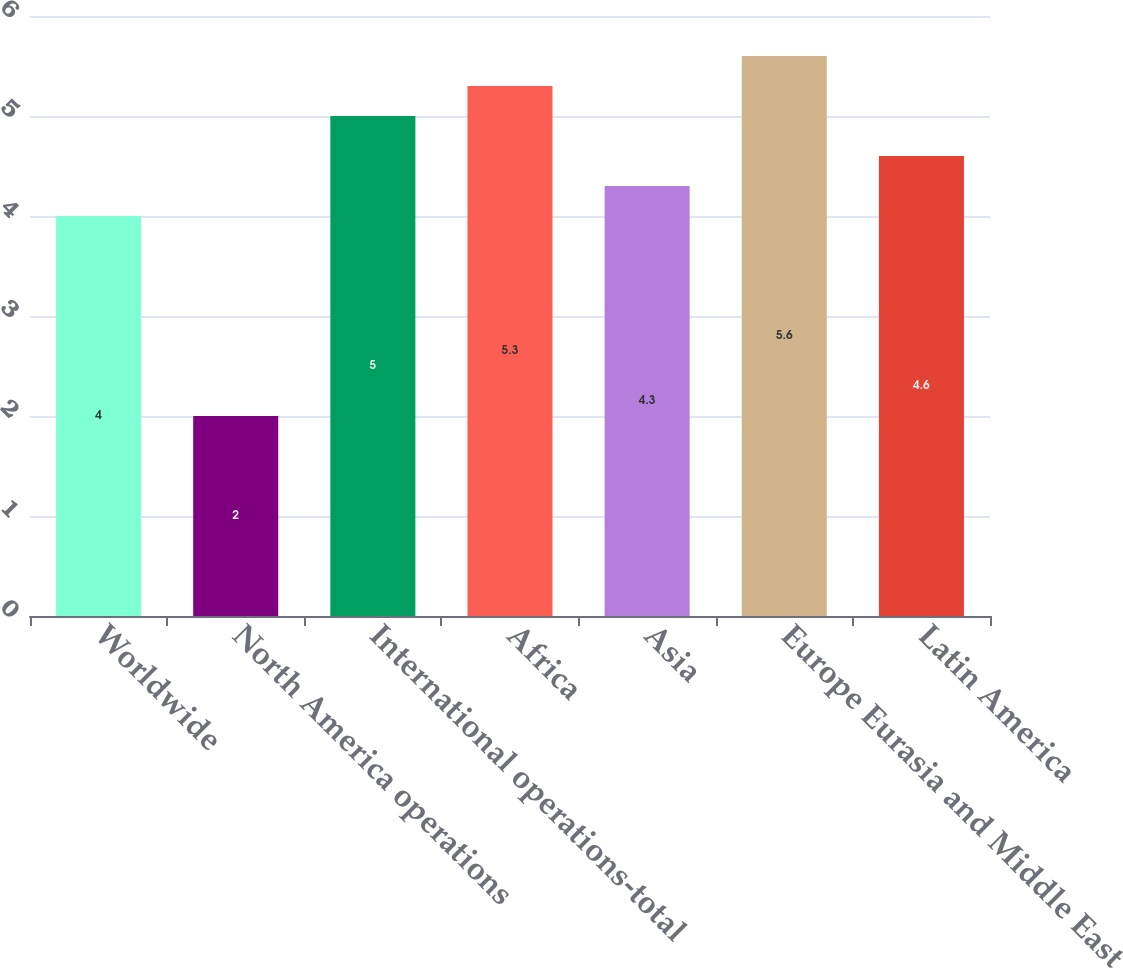Convert chart. <chart><loc_0><loc_0><loc_500><loc_500><bar_chart><fcel>Worldwide<fcel>North America operations<fcel>International operations-total<fcel>Africa<fcel>Asia<fcel>Europe Eurasia and Middle East<fcel>Latin America<nl><fcel>4<fcel>2<fcel>5<fcel>5.3<fcel>4.3<fcel>5.6<fcel>4.6<nl></chart> 